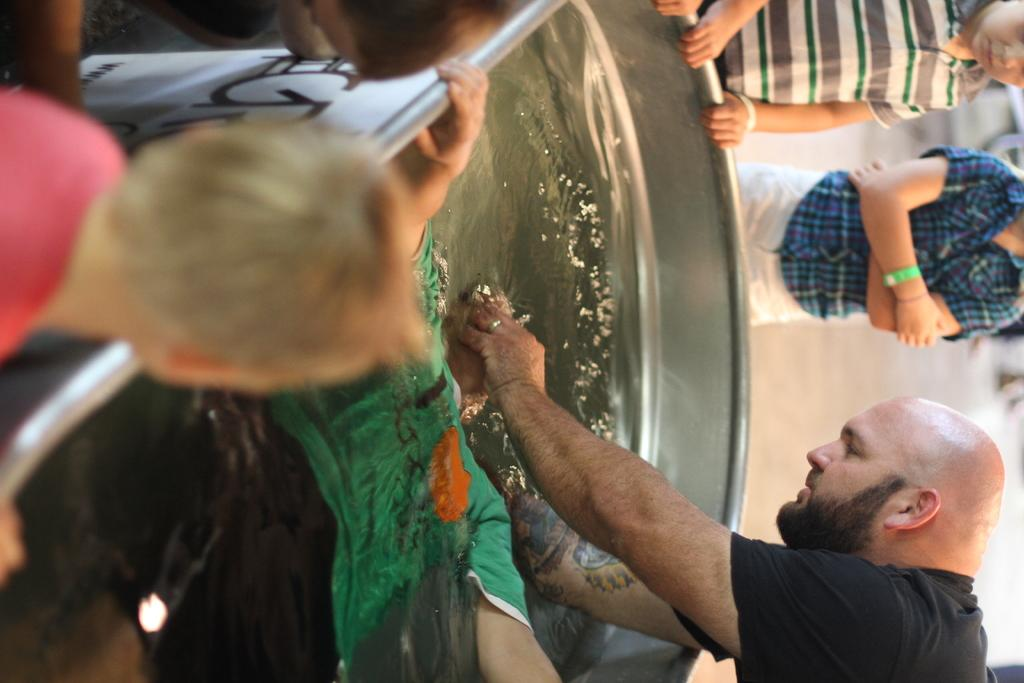What is the orientation of the image? The image is vertical. What is the man in the image wearing? The man is wearing a black t-shirt. What is the man doing with his hands in the image? The man has his hands in a tub of water. Where is the man located in the image? The man is on the right side of the image. Who else is present in the image besides the man? There are kids standing around the tub of water. What type of bag is the man holding in the image? There is no bag present in the image; the man has his hands in a tub of water. How does the dust settle on the rose in the image? There is no rose present in the image, so the question about dust settling on it cannot be answered. 